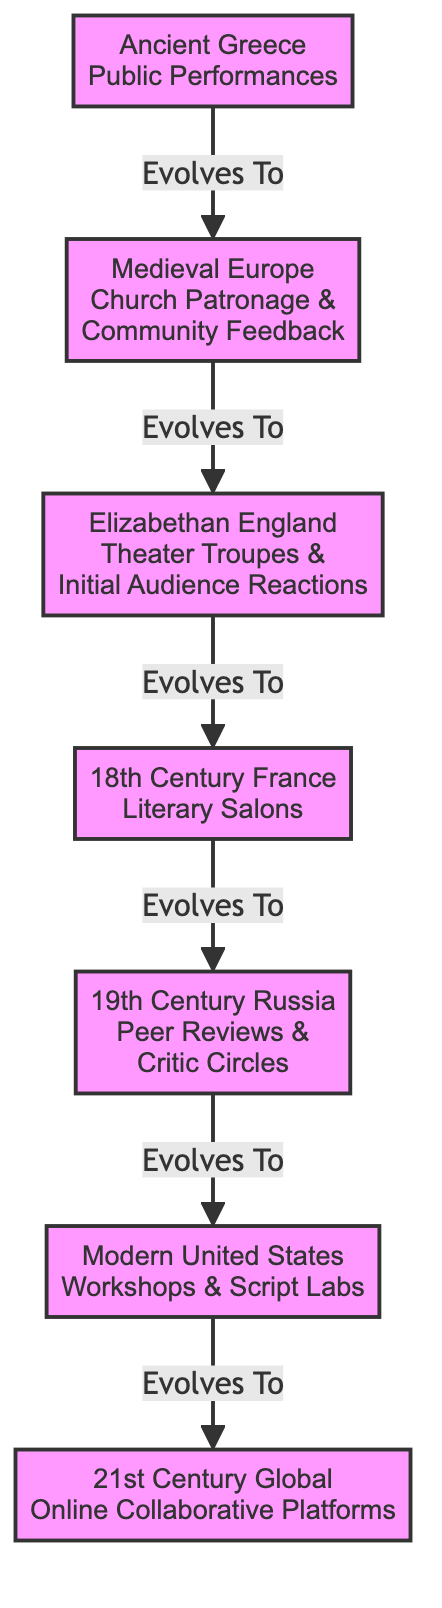What is the first method of script feedback in the diagram? The diagram starts with "Ancient Greece Public Performances" as the first method listed.
Answer: Ancient Greece Public Performances How many total methods of script feedback are represented in the diagram? There are seven distinct methods of script feedback represented in the diagram, each corresponding to a specific cultural context.
Answer: 7 Which method evolves to "Theater Troupes & Initial Audience Reactions"? The method that evolves to "Theater Troupes & Initial Audience Reactions" is "Church Patronage & Community Feedback" from Medieval Europe.
Answer: Church Patronage & Community Feedback In which cultural context did "Literary Salons" emerge? "Literary Salons" emerged in 18th Century France, as indicated by the diagram.
Answer: 18th Century France What is the last method of script feedback mentioned in the diagram? The last method mentioned is "Online Collaborative Platforms," which corresponds to the 21st Century Global context.
Answer: Online Collaborative Platforms Which two methods are connected by the edge labeled "Evolves To"? The edge labeled "Evolves To" connects "Modern United States Workshops & Script Labs" and "21st Century Global Online Collaborative Platforms," indicating a sequence in the evolution of methods.
Answer: Modern United States Workshops & Script Labs and 21st Century Global Online Collaborative Platforms Which method derives from "Peer Reviews & Critic Circles"? The method that derives from "Peer Reviews & Critic Circles" is "Workshops & Script Labs" in Modern United States, showing the progression in feedback methods.
Answer: Workshops & Script Labs What type of diagram is this representation? This representation is a flowchart, specifically illustrating the evolution of script feedback methods across different cultural contexts over time.
Answer: Flowchart 